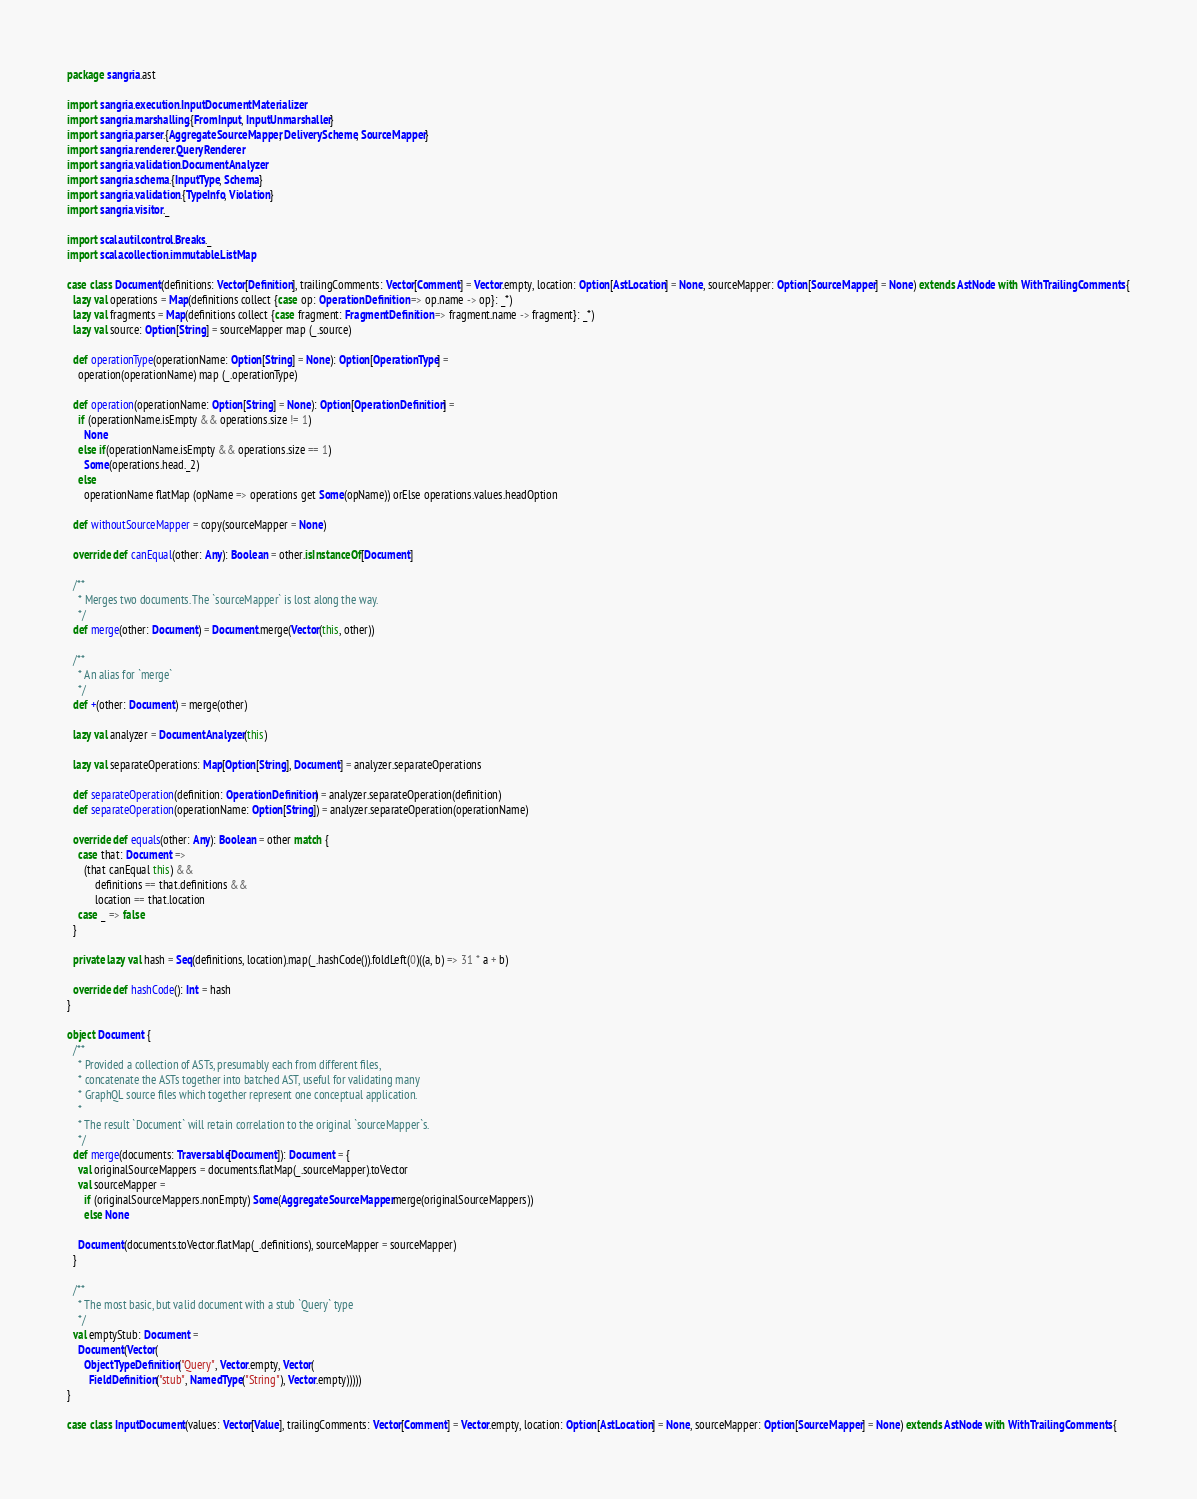Convert code to text. <code><loc_0><loc_0><loc_500><loc_500><_Scala_>package sangria.ast

import sangria.execution.InputDocumentMaterializer
import sangria.marshalling.{FromInput, InputUnmarshaller}
import sangria.parser.{AggregateSourceMapper, DeliveryScheme, SourceMapper}
import sangria.renderer.QueryRenderer
import sangria.validation.DocumentAnalyzer
import sangria.schema.{InputType, Schema}
import sangria.validation.{TypeInfo, Violation}
import sangria.visitor._

import scala.util.control.Breaks._
import scala.collection.immutable.ListMap

case class Document(definitions: Vector[Definition], trailingComments: Vector[Comment] = Vector.empty, location: Option[AstLocation] = None, sourceMapper: Option[SourceMapper] = None) extends AstNode with WithTrailingComments {
  lazy val operations = Map(definitions collect {case op: OperationDefinition => op.name -> op}: _*)
  lazy val fragments = Map(definitions collect {case fragment: FragmentDefinition => fragment.name -> fragment}: _*)
  lazy val source: Option[String] = sourceMapper map (_.source)

  def operationType(operationName: Option[String] = None): Option[OperationType] =
    operation(operationName) map (_.operationType)

  def operation(operationName: Option[String] = None): Option[OperationDefinition] =
    if (operationName.isEmpty && operations.size != 1)
      None
    else if(operationName.isEmpty && operations.size == 1)
      Some(operations.head._2)
    else
      operationName flatMap (opName => operations get Some(opName)) orElse operations.values.headOption

  def withoutSourceMapper = copy(sourceMapper = None)

  override def canEqual(other: Any): Boolean = other.isInstanceOf[Document]

  /**
    * Merges two documents. The `sourceMapper` is lost along the way.
    */
  def merge(other: Document) = Document.merge(Vector(this, other))

  /**
    * An alias for `merge`
    */
  def +(other: Document) = merge(other)

  lazy val analyzer = DocumentAnalyzer(this)

  lazy val separateOperations: Map[Option[String], Document] = analyzer.separateOperations

  def separateOperation(definition: OperationDefinition) = analyzer.separateOperation(definition)
  def separateOperation(operationName: Option[String]) = analyzer.separateOperation(operationName)

  override def equals(other: Any): Boolean = other match {
    case that: Document =>
      (that canEqual this) &&
          definitions == that.definitions &&
          location == that.location
    case _ => false
  }

  private lazy val hash = Seq(definitions, location).map(_.hashCode()).foldLeft(0)((a, b) => 31 * a + b)

  override def hashCode(): Int = hash
}

object Document {
  /**
    * Provided a collection of ASTs, presumably each from different files,
    * concatenate the ASTs together into batched AST, useful for validating many
    * GraphQL source files which together represent one conceptual application.
    *
    * The result `Document` will retain correlation to the original `sourceMapper`s.
    */
  def merge(documents: Traversable[Document]): Document = {
    val originalSourceMappers = documents.flatMap(_.sourceMapper).toVector
    val sourceMapper =
      if (originalSourceMappers.nonEmpty) Some(AggregateSourceMapper.merge(originalSourceMappers))
      else None

    Document(documents.toVector.flatMap(_.definitions), sourceMapper = sourceMapper)
  }

  /**
    * The most basic, but valid document with a stub `Query` type
    */
  val emptyStub: Document =
    Document(Vector(
      ObjectTypeDefinition("Query", Vector.empty, Vector(
        FieldDefinition("stub", NamedType("String"), Vector.empty)))))
}

case class InputDocument(values: Vector[Value], trailingComments: Vector[Comment] = Vector.empty, location: Option[AstLocation] = None, sourceMapper: Option[SourceMapper] = None) extends AstNode with WithTrailingComments {</code> 